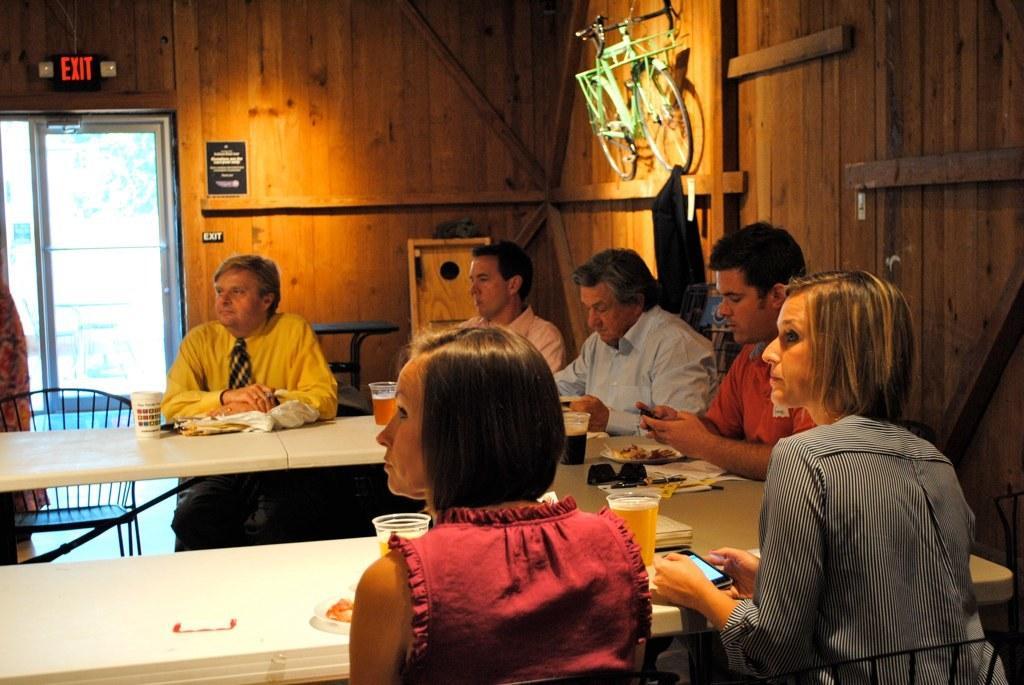In one or two sentences, can you explain what this image depicts? There are group of people sitting on a chairs. This is a table. On this table there is a tumbler,some food items,goggles,plate and some other objects are placed on the table. At background I can see a bicycle attached to the wall. This is the exit light. This is a chair,and I think this is the entrance door. 